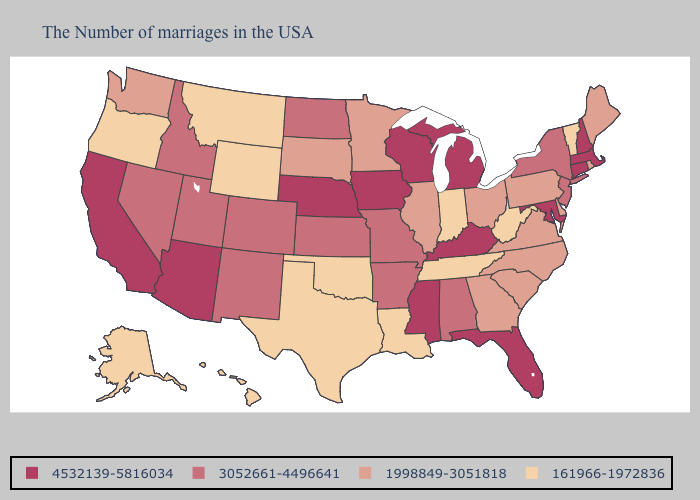Among the states that border Colorado , does Arizona have the highest value?
Be succinct. Yes. Name the states that have a value in the range 4532139-5816034?
Concise answer only. Massachusetts, New Hampshire, Connecticut, Maryland, Florida, Michigan, Kentucky, Wisconsin, Mississippi, Iowa, Nebraska, Arizona, California. Among the states that border Missouri , which have the highest value?
Keep it brief. Kentucky, Iowa, Nebraska. Among the states that border Vermont , which have the lowest value?
Answer briefly. New York. Does Vermont have the lowest value in the Northeast?
Keep it brief. Yes. Does Indiana have the lowest value in the MidWest?
Keep it brief. Yes. Which states have the lowest value in the USA?
Answer briefly. Vermont, West Virginia, Indiana, Tennessee, Louisiana, Oklahoma, Texas, Wyoming, Montana, Oregon, Alaska, Hawaii. Name the states that have a value in the range 4532139-5816034?
Give a very brief answer. Massachusetts, New Hampshire, Connecticut, Maryland, Florida, Michigan, Kentucky, Wisconsin, Mississippi, Iowa, Nebraska, Arizona, California. What is the highest value in the USA?
Concise answer only. 4532139-5816034. Does Texas have a higher value than Iowa?
Be succinct. No. Does Nebraska have a lower value than Arkansas?
Answer briefly. No. Name the states that have a value in the range 161966-1972836?
Concise answer only. Vermont, West Virginia, Indiana, Tennessee, Louisiana, Oklahoma, Texas, Wyoming, Montana, Oregon, Alaska, Hawaii. Which states have the lowest value in the USA?
Concise answer only. Vermont, West Virginia, Indiana, Tennessee, Louisiana, Oklahoma, Texas, Wyoming, Montana, Oregon, Alaska, Hawaii. Which states have the highest value in the USA?
Concise answer only. Massachusetts, New Hampshire, Connecticut, Maryland, Florida, Michigan, Kentucky, Wisconsin, Mississippi, Iowa, Nebraska, Arizona, California. 